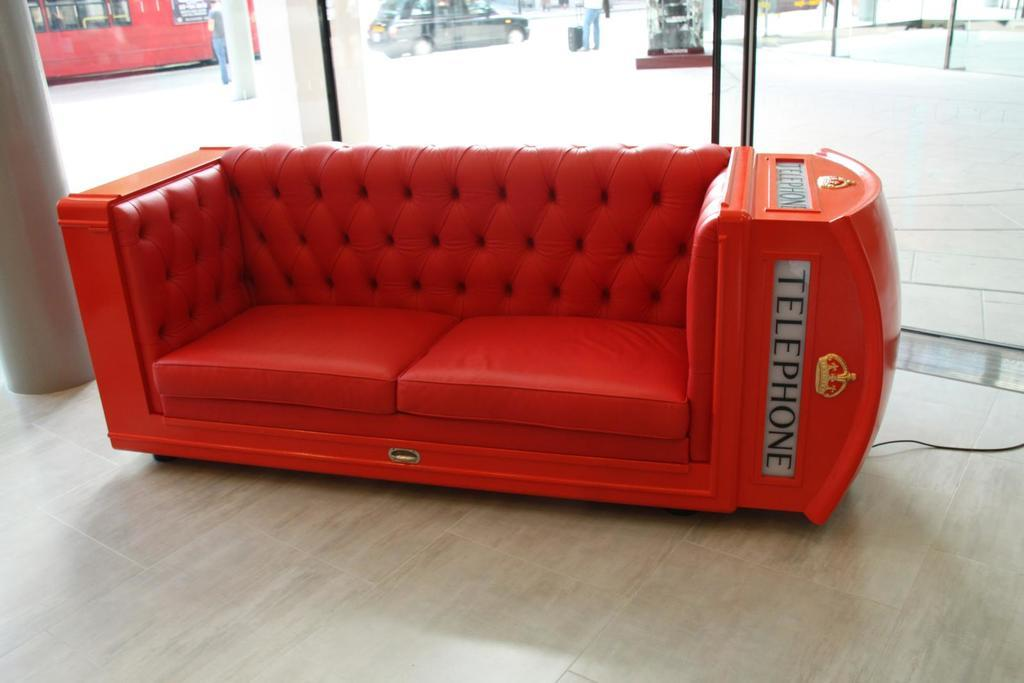What type of furniture is in the image? There is a couch in the image. What can be seen in the background of the image? Vehicles are visible in the background. What are the people in the image doing? There are people standing on the side of the road. What is one person holding? One person is holding a brisket. What type of error is being corrected in the image? There is no indication of an error or correction in the image. What route are the vehicles taking in the image? The image does not show the vehicles' route; it only shows them in the background. 